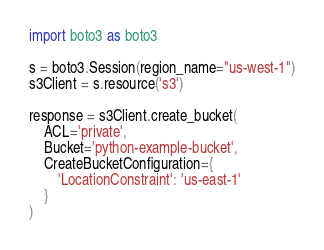Convert code to text. <code><loc_0><loc_0><loc_500><loc_500><_Python_>import boto3 as boto3

s = boto3.Session(region_name="us-west-1")
s3Client = s.resource('s3')

response = s3Client.create_bucket(
    ACL='private',
    Bucket='python-example-bucket',
    CreateBucketConfiguration={
        'LocationConstraint': 'us-east-1'
    }
)
</code> 